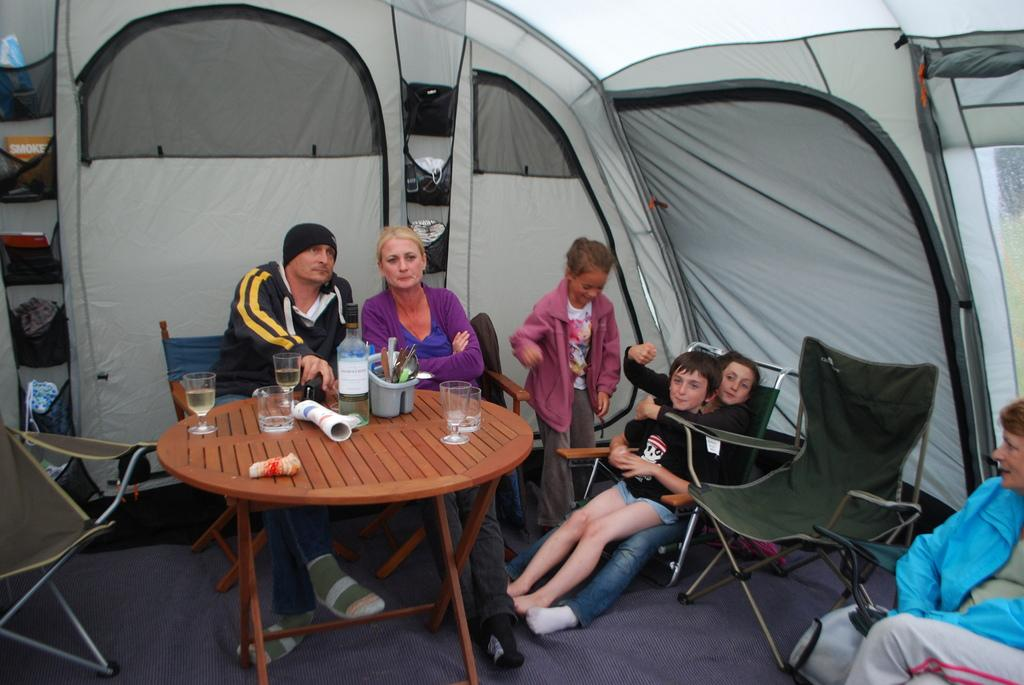What is the setting of the image? The image is inside a tent. What are the people in the image doing? There are people sitting on chairs in the image. What activity is taking place in the image? There is a race happening in the image. What furniture is present in the image? There is a table in the image. What items can be seen on the table? There are glasses, a bottle, and a holder on the table. What type of notebook can be seen on the table in the image? There is no notebook present on the table in the image. What curve can be observed in the image? There is no curve mentioned or visible in the image. 